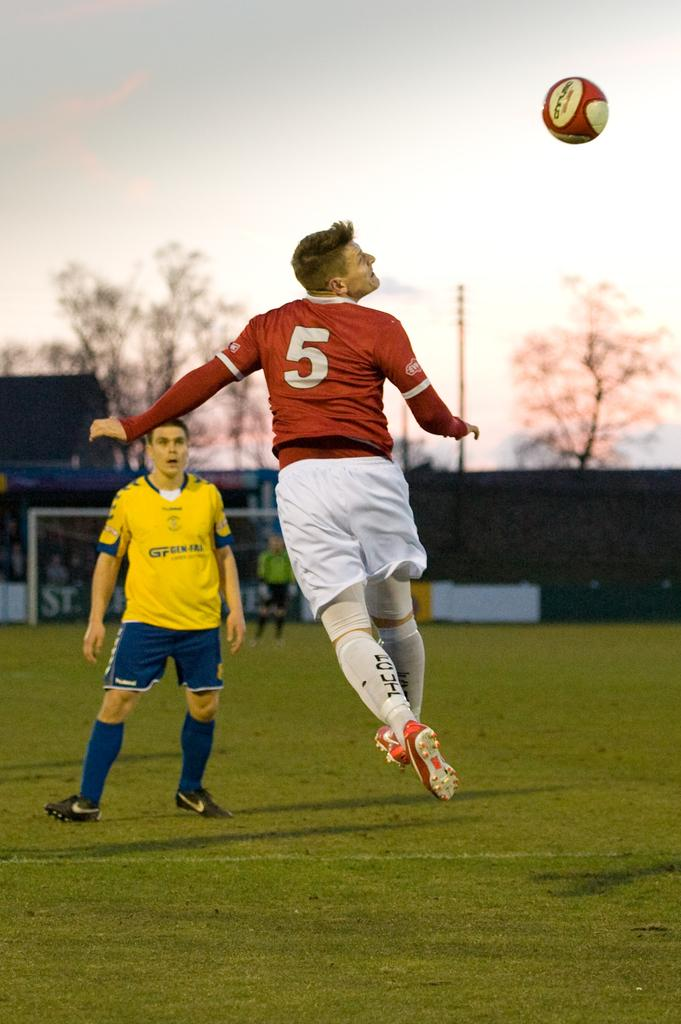Provide a one-sentence caption for the provided image. Two soccer players are trying to reach the ball and the player in a red jersey with a 5 on it is closest to the ball. 